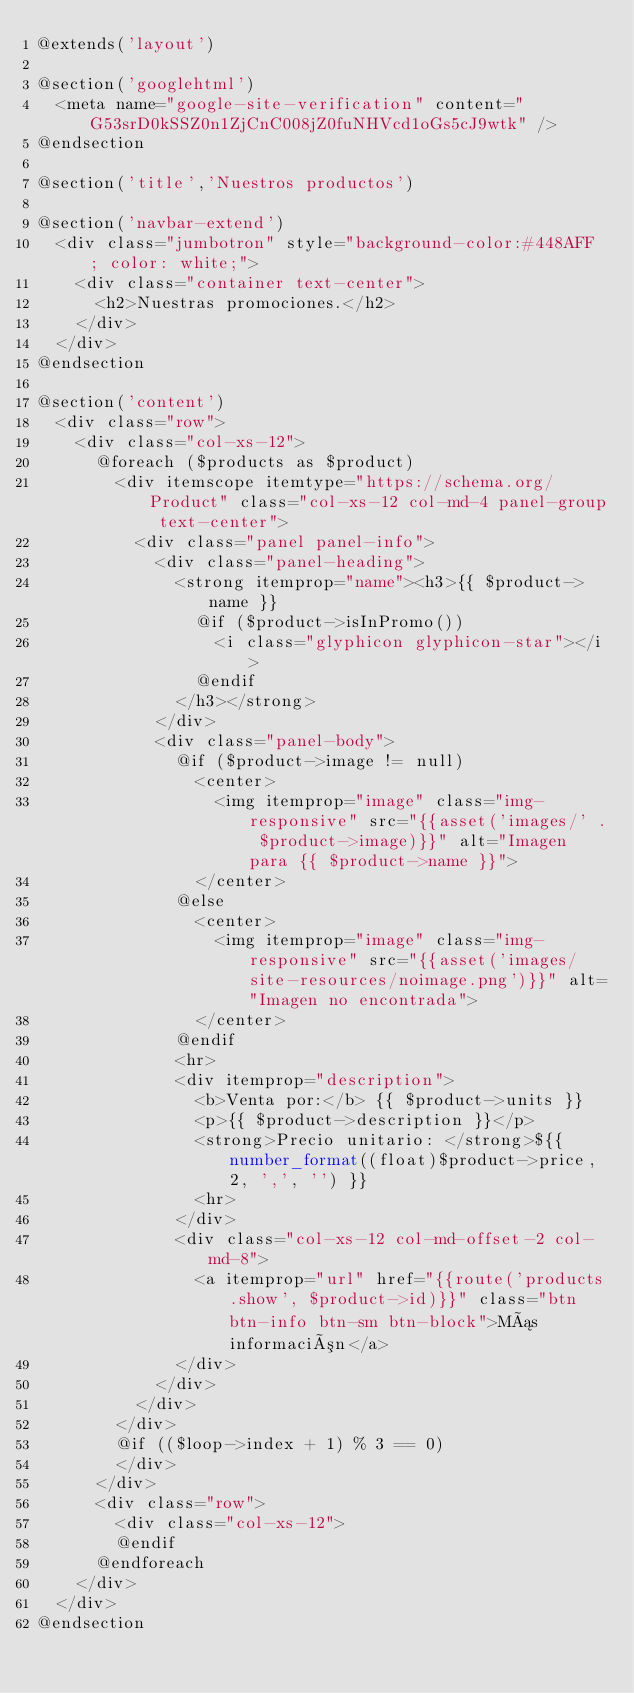Convert code to text. <code><loc_0><loc_0><loc_500><loc_500><_PHP_>@extends('layout')

@section('googlehtml')
  <meta name="google-site-verification" content="G53srD0kSSZ0n1ZjCnC008jZ0fuNHVcd1oGs5cJ9wtk" />
@endsection

@section('title','Nuestros productos')

@section('navbar-extend')
  <div class="jumbotron" style="background-color:#448AFF ; color: white;">
    <div class="container text-center">
      <h2>Nuestras promociones.</h2>
    </div>
  </div>
@endsection

@section('content')
  <div class="row">
    <div class="col-xs-12">
      @foreach ($products as $product)
        <div itemscope itemtype="https://schema.org/Product" class="col-xs-12 col-md-4 panel-group text-center">
          <div class="panel panel-info">
            <div class="panel-heading">
              <strong itemprop="name"><h3>{{ $product->name }}
                @if ($product->isInPromo())
                  <i class="glyphicon glyphicon-star"></i>
                @endif
              </h3></strong>
            </div>
            <div class="panel-body">
              @if ($product->image != null)
                <center>
                  <img itemprop="image" class="img-responsive" src="{{asset('images/' . $product->image)}}" alt="Imagen para {{ $product->name }}">
                </center>
              @else
                <center>
                  <img itemprop="image" class="img-responsive" src="{{asset('images/site-resources/noimage.png')}}" alt="Imagen no encontrada">
                </center>
              @endif
              <hr>
              <div itemprop="description">
                <b>Venta por:</b> {{ $product->units }}
                <p>{{ $product->description }}</p>
                <strong>Precio unitario: </strong>${{ number_format((float)$product->price, 2, ',', '') }}
                <hr>
              </div>
              <div class="col-xs-12 col-md-offset-2 col-md-8">
                <a itemprop="url" href="{{route('products.show', $product->id)}}" class="btn btn-info btn-sm btn-block">Más información</a>
              </div>
            </div>
          </div>
        </div>
        @if (($loop->index + 1) % 3 == 0)
        </div>
      </div>
      <div class="row">
        <div class="col-xs-12">
        @endif
      @endforeach
    </div>
  </div>
@endsection
</code> 